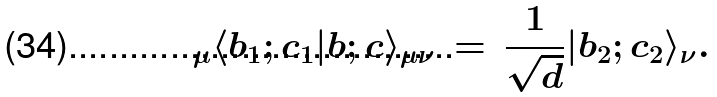<formula> <loc_0><loc_0><loc_500><loc_500>\, _ { \mu } \langle b _ { 1 } ; c _ { 1 } | b ; c \rangle _ { \mu \nu } \, = \, \frac { 1 } { \sqrt { d } } | b _ { 2 } ; c _ { 2 } \rangle _ { \nu } .</formula> 